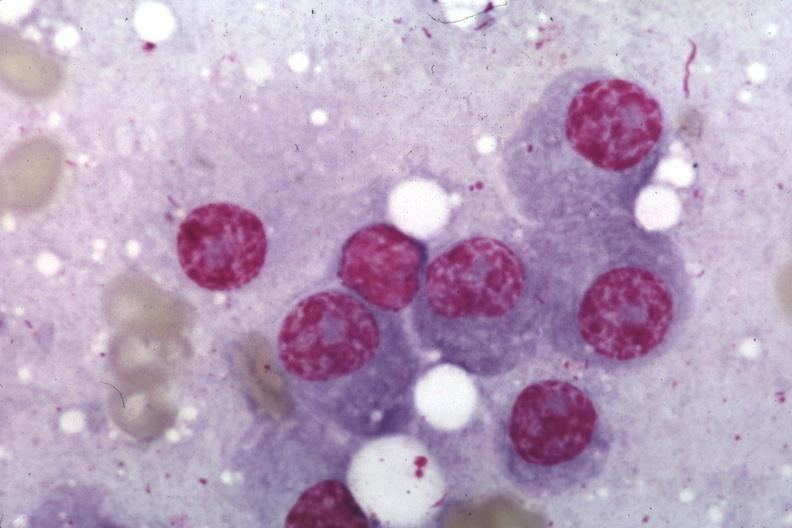what is present?
Answer the question using a single word or phrase. Multiple myeloma 